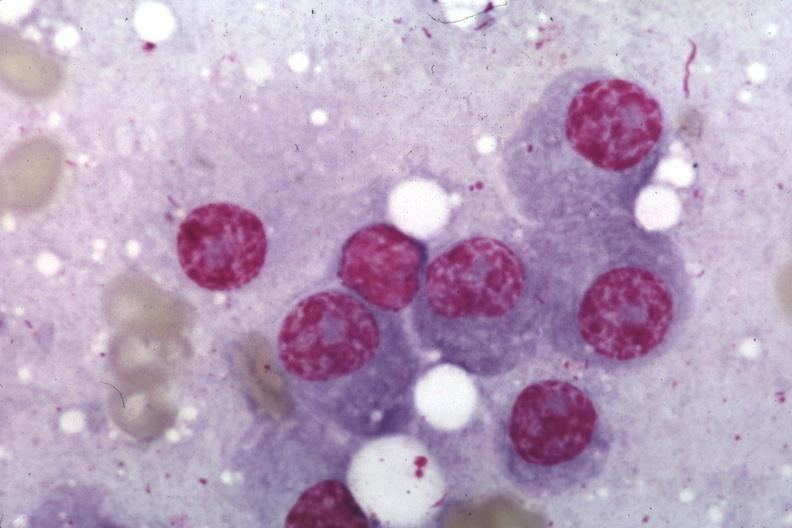what is present?
Answer the question using a single word or phrase. Multiple myeloma 